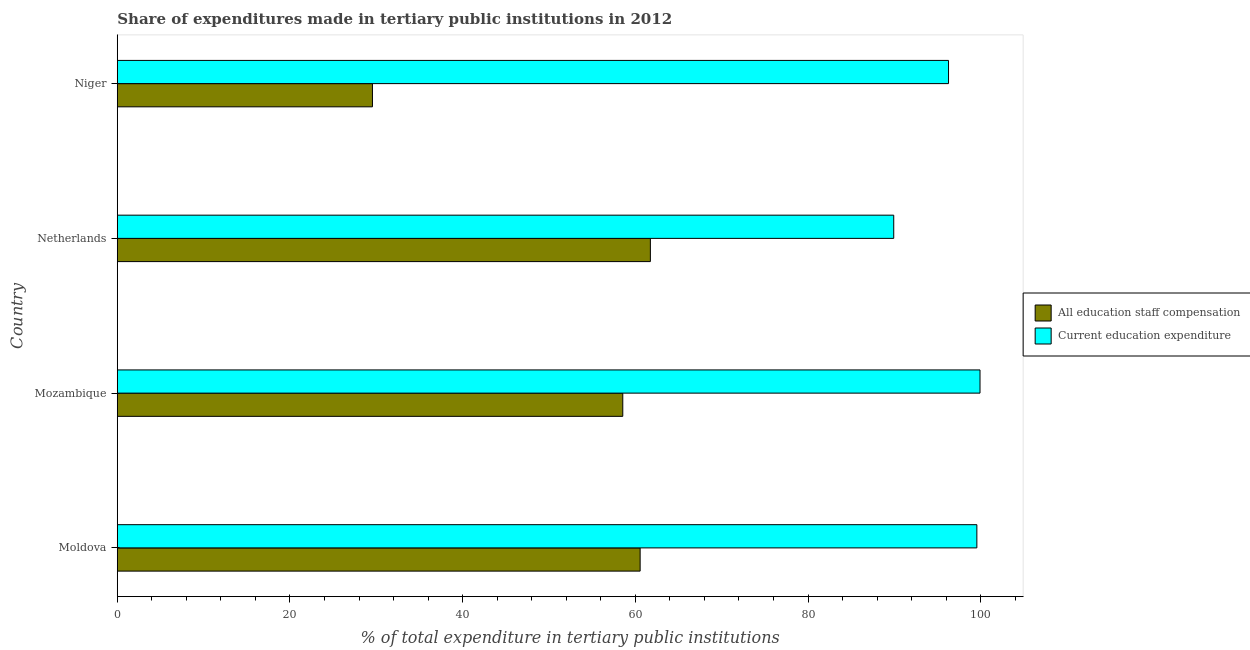How many different coloured bars are there?
Your answer should be very brief. 2. How many groups of bars are there?
Provide a short and direct response. 4. Are the number of bars per tick equal to the number of legend labels?
Your answer should be compact. Yes. How many bars are there on the 1st tick from the top?
Offer a terse response. 2. In how many cases, is the number of bars for a given country not equal to the number of legend labels?
Provide a succinct answer. 0. What is the expenditure in education in Mozambique?
Ensure brevity in your answer.  99.92. Across all countries, what is the maximum expenditure in staff compensation?
Your answer should be compact. 61.74. Across all countries, what is the minimum expenditure in education?
Ensure brevity in your answer.  89.93. In which country was the expenditure in education maximum?
Your answer should be compact. Mozambique. In which country was the expenditure in education minimum?
Ensure brevity in your answer.  Netherlands. What is the total expenditure in education in the graph?
Your response must be concise. 385.69. What is the difference between the expenditure in education in Moldova and that in Mozambique?
Keep it short and to the point. -0.37. What is the difference between the expenditure in education in Netherlands and the expenditure in staff compensation in Moldova?
Provide a short and direct response. 29.37. What is the average expenditure in staff compensation per country?
Ensure brevity in your answer.  52.6. What is the difference between the expenditure in education and expenditure in staff compensation in Niger?
Provide a succinct answer. 66.72. What is the ratio of the expenditure in education in Moldova to that in Niger?
Ensure brevity in your answer.  1.03. What is the difference between the highest and the second highest expenditure in staff compensation?
Your answer should be very brief. 1.19. What is the difference between the highest and the lowest expenditure in staff compensation?
Your answer should be compact. 32.19. What does the 1st bar from the top in Moldova represents?
Your response must be concise. Current education expenditure. What does the 2nd bar from the bottom in Moldova represents?
Give a very brief answer. Current education expenditure. How many bars are there?
Your answer should be compact. 8. What is the difference between two consecutive major ticks on the X-axis?
Your answer should be very brief. 20. Are the values on the major ticks of X-axis written in scientific E-notation?
Keep it short and to the point. No. Does the graph contain any zero values?
Offer a terse response. No. Where does the legend appear in the graph?
Your response must be concise. Center right. How many legend labels are there?
Offer a terse response. 2. How are the legend labels stacked?
Provide a succinct answer. Vertical. What is the title of the graph?
Provide a short and direct response. Share of expenditures made in tertiary public institutions in 2012. Does "All education staff compensation" appear as one of the legend labels in the graph?
Provide a short and direct response. Yes. What is the label or title of the X-axis?
Make the answer very short. % of total expenditure in tertiary public institutions. What is the label or title of the Y-axis?
Your answer should be compact. Country. What is the % of total expenditure in tertiary public institutions of All education staff compensation in Moldova?
Your answer should be very brief. 60.56. What is the % of total expenditure in tertiary public institutions in Current education expenditure in Moldova?
Your response must be concise. 99.56. What is the % of total expenditure in tertiary public institutions in All education staff compensation in Mozambique?
Your response must be concise. 58.55. What is the % of total expenditure in tertiary public institutions in Current education expenditure in Mozambique?
Keep it short and to the point. 99.92. What is the % of total expenditure in tertiary public institutions in All education staff compensation in Netherlands?
Keep it short and to the point. 61.74. What is the % of total expenditure in tertiary public institutions of Current education expenditure in Netherlands?
Your answer should be compact. 89.93. What is the % of total expenditure in tertiary public institutions of All education staff compensation in Niger?
Give a very brief answer. 29.55. What is the % of total expenditure in tertiary public institutions of Current education expenditure in Niger?
Offer a terse response. 96.28. Across all countries, what is the maximum % of total expenditure in tertiary public institutions in All education staff compensation?
Your answer should be very brief. 61.74. Across all countries, what is the maximum % of total expenditure in tertiary public institutions of Current education expenditure?
Offer a terse response. 99.92. Across all countries, what is the minimum % of total expenditure in tertiary public institutions in All education staff compensation?
Offer a very short reply. 29.55. Across all countries, what is the minimum % of total expenditure in tertiary public institutions of Current education expenditure?
Your answer should be very brief. 89.93. What is the total % of total expenditure in tertiary public institutions in All education staff compensation in the graph?
Provide a short and direct response. 210.4. What is the total % of total expenditure in tertiary public institutions of Current education expenditure in the graph?
Offer a terse response. 385.69. What is the difference between the % of total expenditure in tertiary public institutions of All education staff compensation in Moldova and that in Mozambique?
Your response must be concise. 2.01. What is the difference between the % of total expenditure in tertiary public institutions of Current education expenditure in Moldova and that in Mozambique?
Ensure brevity in your answer.  -0.37. What is the difference between the % of total expenditure in tertiary public institutions of All education staff compensation in Moldova and that in Netherlands?
Offer a terse response. -1.19. What is the difference between the % of total expenditure in tertiary public institutions of Current education expenditure in Moldova and that in Netherlands?
Offer a terse response. 9.63. What is the difference between the % of total expenditure in tertiary public institutions of All education staff compensation in Moldova and that in Niger?
Provide a short and direct response. 31. What is the difference between the % of total expenditure in tertiary public institutions of Current education expenditure in Moldova and that in Niger?
Keep it short and to the point. 3.28. What is the difference between the % of total expenditure in tertiary public institutions in All education staff compensation in Mozambique and that in Netherlands?
Keep it short and to the point. -3.2. What is the difference between the % of total expenditure in tertiary public institutions of Current education expenditure in Mozambique and that in Netherlands?
Provide a succinct answer. 9.99. What is the difference between the % of total expenditure in tertiary public institutions of All education staff compensation in Mozambique and that in Niger?
Provide a short and direct response. 28.99. What is the difference between the % of total expenditure in tertiary public institutions of Current education expenditure in Mozambique and that in Niger?
Ensure brevity in your answer.  3.65. What is the difference between the % of total expenditure in tertiary public institutions of All education staff compensation in Netherlands and that in Niger?
Your response must be concise. 32.19. What is the difference between the % of total expenditure in tertiary public institutions in Current education expenditure in Netherlands and that in Niger?
Offer a terse response. -6.35. What is the difference between the % of total expenditure in tertiary public institutions in All education staff compensation in Moldova and the % of total expenditure in tertiary public institutions in Current education expenditure in Mozambique?
Offer a terse response. -39.37. What is the difference between the % of total expenditure in tertiary public institutions of All education staff compensation in Moldova and the % of total expenditure in tertiary public institutions of Current education expenditure in Netherlands?
Provide a short and direct response. -29.37. What is the difference between the % of total expenditure in tertiary public institutions in All education staff compensation in Moldova and the % of total expenditure in tertiary public institutions in Current education expenditure in Niger?
Offer a very short reply. -35.72. What is the difference between the % of total expenditure in tertiary public institutions of All education staff compensation in Mozambique and the % of total expenditure in tertiary public institutions of Current education expenditure in Netherlands?
Your response must be concise. -31.38. What is the difference between the % of total expenditure in tertiary public institutions of All education staff compensation in Mozambique and the % of total expenditure in tertiary public institutions of Current education expenditure in Niger?
Give a very brief answer. -37.73. What is the difference between the % of total expenditure in tertiary public institutions of All education staff compensation in Netherlands and the % of total expenditure in tertiary public institutions of Current education expenditure in Niger?
Keep it short and to the point. -34.53. What is the average % of total expenditure in tertiary public institutions of All education staff compensation per country?
Offer a terse response. 52.6. What is the average % of total expenditure in tertiary public institutions in Current education expenditure per country?
Keep it short and to the point. 96.42. What is the difference between the % of total expenditure in tertiary public institutions in All education staff compensation and % of total expenditure in tertiary public institutions in Current education expenditure in Moldova?
Your response must be concise. -39. What is the difference between the % of total expenditure in tertiary public institutions of All education staff compensation and % of total expenditure in tertiary public institutions of Current education expenditure in Mozambique?
Your answer should be very brief. -41.38. What is the difference between the % of total expenditure in tertiary public institutions in All education staff compensation and % of total expenditure in tertiary public institutions in Current education expenditure in Netherlands?
Keep it short and to the point. -28.19. What is the difference between the % of total expenditure in tertiary public institutions of All education staff compensation and % of total expenditure in tertiary public institutions of Current education expenditure in Niger?
Provide a short and direct response. -66.72. What is the ratio of the % of total expenditure in tertiary public institutions of All education staff compensation in Moldova to that in Mozambique?
Provide a short and direct response. 1.03. What is the ratio of the % of total expenditure in tertiary public institutions of Current education expenditure in Moldova to that in Mozambique?
Ensure brevity in your answer.  1. What is the ratio of the % of total expenditure in tertiary public institutions in All education staff compensation in Moldova to that in Netherlands?
Make the answer very short. 0.98. What is the ratio of the % of total expenditure in tertiary public institutions in Current education expenditure in Moldova to that in Netherlands?
Your answer should be compact. 1.11. What is the ratio of the % of total expenditure in tertiary public institutions in All education staff compensation in Moldova to that in Niger?
Provide a short and direct response. 2.05. What is the ratio of the % of total expenditure in tertiary public institutions of Current education expenditure in Moldova to that in Niger?
Your response must be concise. 1.03. What is the ratio of the % of total expenditure in tertiary public institutions in All education staff compensation in Mozambique to that in Netherlands?
Make the answer very short. 0.95. What is the ratio of the % of total expenditure in tertiary public institutions of Current education expenditure in Mozambique to that in Netherlands?
Ensure brevity in your answer.  1.11. What is the ratio of the % of total expenditure in tertiary public institutions in All education staff compensation in Mozambique to that in Niger?
Offer a very short reply. 1.98. What is the ratio of the % of total expenditure in tertiary public institutions in Current education expenditure in Mozambique to that in Niger?
Ensure brevity in your answer.  1.04. What is the ratio of the % of total expenditure in tertiary public institutions in All education staff compensation in Netherlands to that in Niger?
Provide a succinct answer. 2.09. What is the ratio of the % of total expenditure in tertiary public institutions in Current education expenditure in Netherlands to that in Niger?
Provide a succinct answer. 0.93. What is the difference between the highest and the second highest % of total expenditure in tertiary public institutions in All education staff compensation?
Provide a short and direct response. 1.19. What is the difference between the highest and the second highest % of total expenditure in tertiary public institutions in Current education expenditure?
Offer a terse response. 0.37. What is the difference between the highest and the lowest % of total expenditure in tertiary public institutions in All education staff compensation?
Your answer should be very brief. 32.19. What is the difference between the highest and the lowest % of total expenditure in tertiary public institutions in Current education expenditure?
Provide a succinct answer. 9.99. 